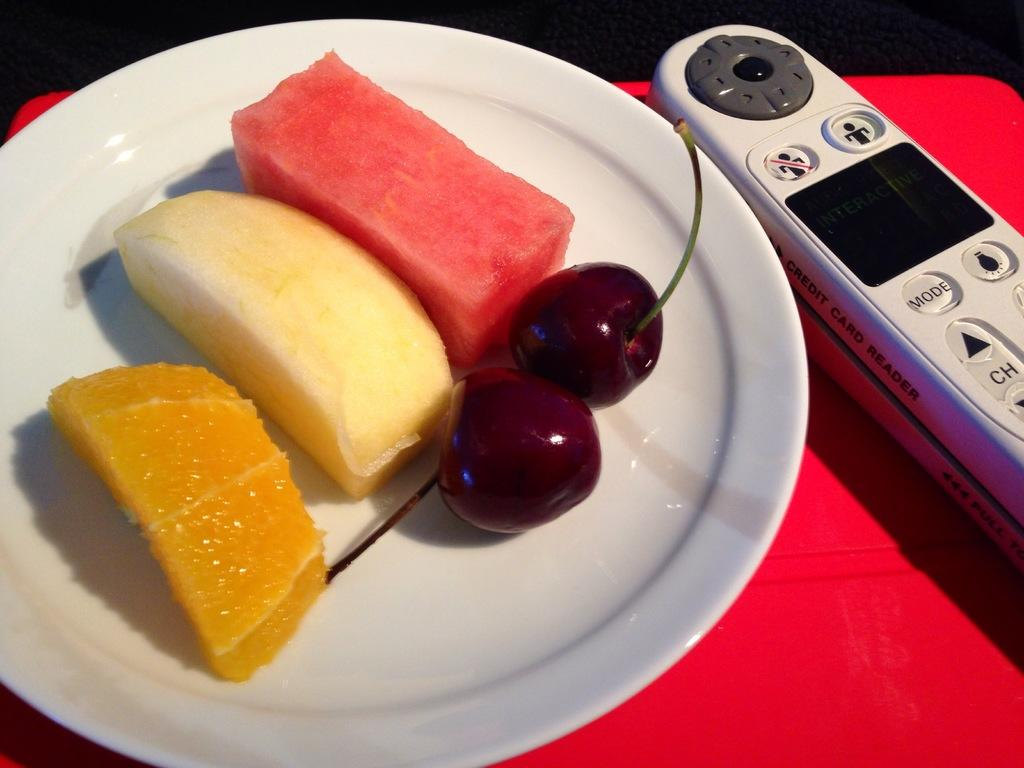<image>
Provide a brief description of the given image. A white plate of fruit with a white wireless handset up down channel selector icons 